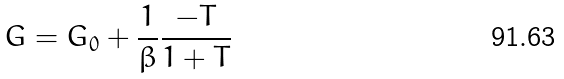Convert formula to latex. <formula><loc_0><loc_0><loc_500><loc_500>G = G _ { 0 } + \frac { 1 } { \beta } \frac { - T } { 1 + T }</formula> 